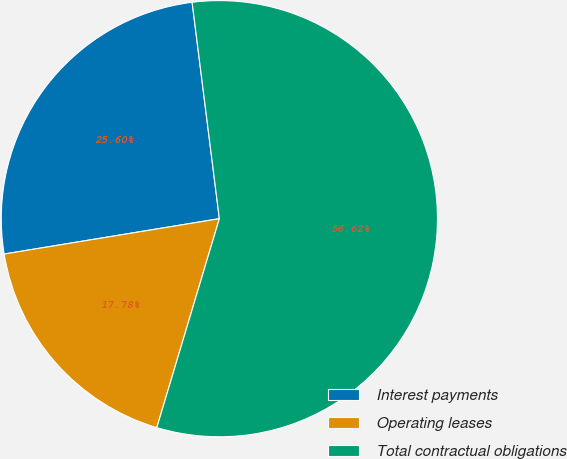<chart> <loc_0><loc_0><loc_500><loc_500><pie_chart><fcel>Interest payments<fcel>Operating leases<fcel>Total contractual obligations<nl><fcel>25.6%<fcel>17.78%<fcel>56.63%<nl></chart> 